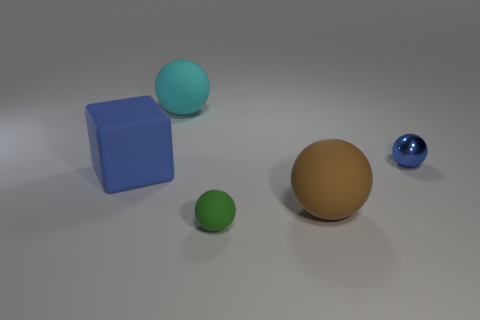Add 4 tiny brown metal balls. How many objects exist? 9 Subtract all cubes. How many objects are left? 4 Subtract all tiny shiny cylinders. Subtract all tiny objects. How many objects are left? 3 Add 2 blue metallic objects. How many blue metallic objects are left? 3 Add 1 small purple cylinders. How many small purple cylinders exist? 1 Subtract 0 yellow spheres. How many objects are left? 5 